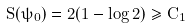<formula> <loc_0><loc_0><loc_500><loc_500>S ( \psi _ { 0 } ) = 2 ( 1 - \log 2 ) \geq C _ { 1 }</formula> 